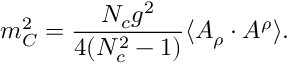Convert formula to latex. <formula><loc_0><loc_0><loc_500><loc_500>m _ { C } ^ { 2 } = \frac { N _ { c } g ^ { 2 } } { 4 ( N _ { c } ^ { 2 } - 1 ) } \langle A _ { \rho } \cdot A ^ { \rho } \rangle .</formula> 